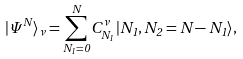Convert formula to latex. <formula><loc_0><loc_0><loc_500><loc_500>| \Psi ^ { N } \rangle _ { \nu } = \sum _ { N _ { 1 } = 0 } ^ { N } C ^ { \nu } _ { N _ { 1 } } | N _ { 1 } , N _ { 2 } = N - N _ { 1 } \rangle ,</formula> 